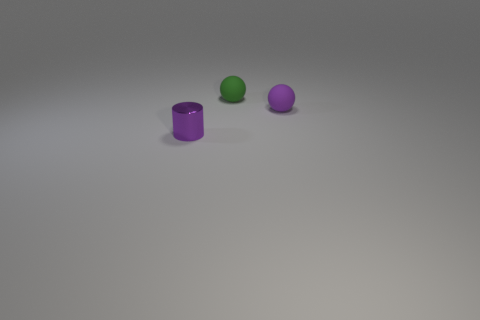Are there any other things that have the same material as the small cylinder?
Offer a terse response. No. Are there any other things that have the same color as the small shiny cylinder?
Your response must be concise. Yes. There is a small thing on the left side of the small green ball; what shape is it?
Your answer should be compact. Cylinder. Do the shiny cylinder and the rubber thing in front of the green ball have the same color?
Your answer should be very brief. Yes. Are there the same number of cylinders that are on the left side of the green rubber sphere and green rubber balls to the left of the small cylinder?
Keep it short and to the point. No. What number of other objects are there of the same size as the green matte object?
Provide a short and direct response. 2. The green rubber ball is what size?
Your answer should be very brief. Small. Is the cylinder made of the same material as the purple object that is behind the tiny cylinder?
Offer a terse response. No. Are there any purple matte things that have the same shape as the small purple metallic thing?
Your answer should be very brief. No. There is a purple thing that is the same size as the purple metallic cylinder; what material is it?
Offer a terse response. Rubber. 